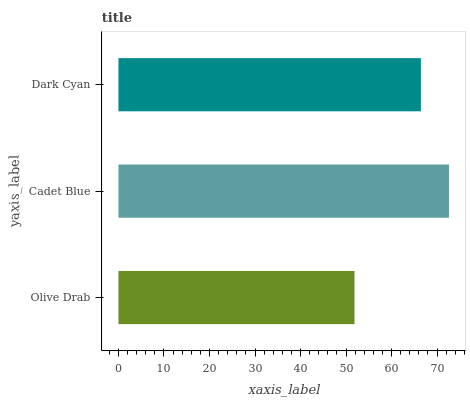Is Olive Drab the minimum?
Answer yes or no. Yes. Is Cadet Blue the maximum?
Answer yes or no. Yes. Is Dark Cyan the minimum?
Answer yes or no. No. Is Dark Cyan the maximum?
Answer yes or no. No. Is Cadet Blue greater than Dark Cyan?
Answer yes or no. Yes. Is Dark Cyan less than Cadet Blue?
Answer yes or no. Yes. Is Dark Cyan greater than Cadet Blue?
Answer yes or no. No. Is Cadet Blue less than Dark Cyan?
Answer yes or no. No. Is Dark Cyan the high median?
Answer yes or no. Yes. Is Dark Cyan the low median?
Answer yes or no. Yes. Is Cadet Blue the high median?
Answer yes or no. No. Is Cadet Blue the low median?
Answer yes or no. No. 